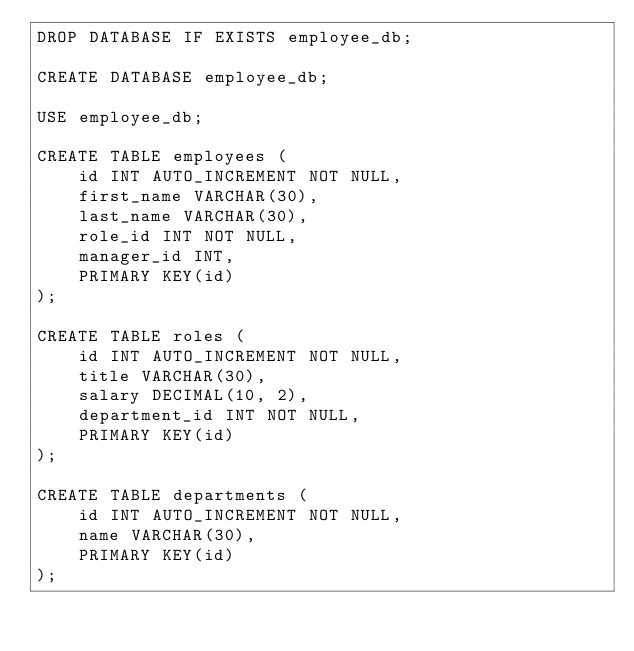Convert code to text. <code><loc_0><loc_0><loc_500><loc_500><_SQL_>DROP DATABASE IF EXISTS employee_db;

CREATE DATABASE employee_db;

USE employee_db;

CREATE TABLE employees (
    id INT AUTO_INCREMENT NOT NULL,
    first_name VARCHAR(30),
    last_name VARCHAR(30),
    role_id INT NOT NULL,
    manager_id INT,
    PRIMARY KEY(id)
);

CREATE TABLE roles (
    id INT AUTO_INCREMENT NOT NULL,
    title VARCHAR(30),
    salary DECIMAL(10, 2),
    department_id INT NOT NULL,
    PRIMARY KEY(id)
);

CREATE TABLE departments (
    id INT AUTO_INCREMENT NOT NULL,
    name VARCHAR(30),
    PRIMARY KEY(id)
);</code> 